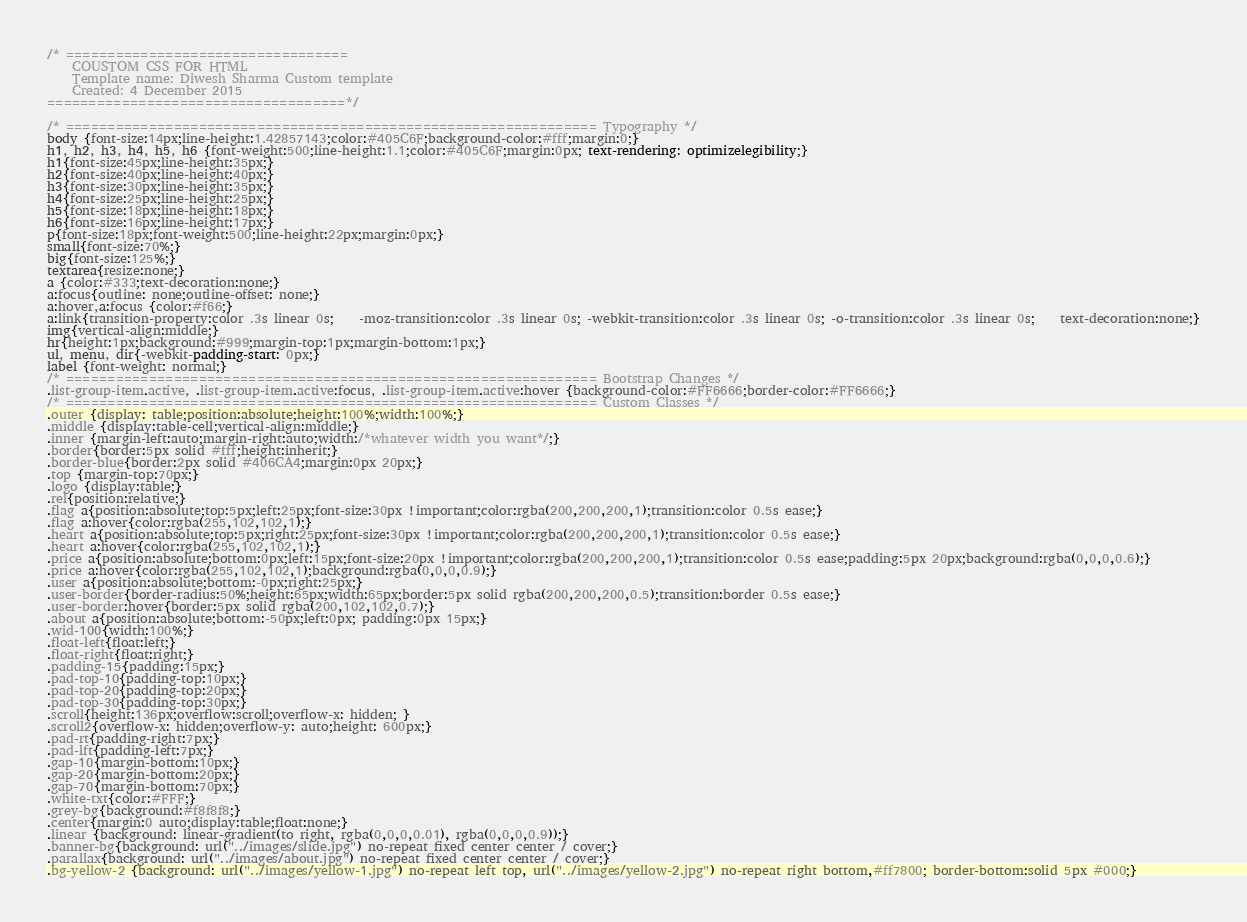<code> <loc_0><loc_0><loc_500><loc_500><_CSS_>/* ==================================
	COUSTOM CSS FOR HTML
	Template name: Diwesh Sharma Custom template
	Created: 4 December 2015       
====================================*/

/* ================================================================ Typography */
body {font-size:14px;line-height:1.42857143;color:#405C6F;background-color:#fff;margin:0;}
h1, h2, h3, h4, h5, h6 {font-weight:500;line-height:1.1;color:#405C6F;margin:0px; text-rendering: optimizelegibility;}
h1{font-size:45px;line-height:35px;}
h2{font-size:40px;line-height:40px;}
h3{font-size:30px;line-height:35px;}
h4{font-size:25px;line-height:25px;}
h5{font-size:18px;line-height:18px;}
h6{font-size:16px;line-height:17px;}
p{font-size:18px;font-weight:500;line-height:22px;margin:0px;}
small{font-size:70%;}
big{font-size:125%;}
textarea{resize:none;}
a {color:#333;text-decoration:none;}
a:focus{outline: none;outline-offset: none;}
a:hover,a:focus {color:#f66;}
a:link{transition-property:color .3s linear 0s;	-moz-transition:color .3s linear 0s; -webkit-transition:color .3s linear 0s; -o-transition:color .3s linear 0s;	text-decoration:none;}
img{vertical-align:middle;}
hr{height:1px;background:#999;margin-top:1px;margin-bottom:1px;}
ul, menu, dir{-webkit-padding-start: 0px;}
label {font-weight: normal;}
/* ================================================================ Bootstrap Changes */
.list-group-item.active, .list-group-item.active:focus, .list-group-item.active:hover {background-color:#FF6666;border-color:#FF6666;}
/* ================================================================ Custom Classes */
.outer {display: table;position:absolute;height:100%;width:100%;}
.middle {display:table-cell;vertical-align:middle;}
.inner {margin-left:auto;margin-right:auto;width:/*whatever width you want*/;}
.border{border:5px solid #fff;height:inherit;}
.border-blue{border:2px solid #406CA4;margin:0px 20px;}
.top {margin-top:70px;}
.logo {display:table;}
.rel{position:relative;}
.flag a{position:absolute;top:5px;left:25px;font-size:30px !important;color:rgba(200,200,200,1);transition:color 0.5s ease;}
.flag a:hover{color:rgba(255,102,102,1);}
.heart a{position:absolute;top:5px;right:25px;font-size:30px !important;color:rgba(200,200,200,1);transition:color 0.5s ease;}
.heart a:hover{color:rgba(255,102,102,1);}
.price a{position:absolute;bottom:0px;left:15px;font-size:20px !important;color:rgba(200,200,200,1);transition:color 0.5s ease;padding:5px 20px;background:rgba(0,0,0,0.6);}
.price a:hover{color:rgba(255,102,102,1);background:rgba(0,0,0,0.9);}
.user a{position:absolute;bottom:-0px;right:25px;}
.user-border{border-radius:50%;height:65px;width:65px;border:5px solid rgba(200,200,200,0.5);transition:border 0.5s ease;}
.user-border:hover{border:5px solid rgba(200,102,102,0.7);}
.about a{position:absolute;bottom:-50px;left:0px; padding:0px 15px;}
.wid-100{width:100%;}
.float-left{float:left;}
.float-right{float:right;}
.padding-15{padding:15px;}
.pad-top-10{padding-top:10px;}
.pad-top-20{padding-top:20px;}
.pad-top-30{padding-top:30px;}
.scroll{height:136px;overflow:scroll;overflow-x: hidden; }
.scroll2{overflow-x: hidden;overflow-y: auto;height: 600px;}
.pad-rt{padding-right:7px;}
.pad-lft{padding-left:7px;}
.gap-10{margin-bottom:10px;}
.gap-20{margin-bottom:20px;}
.gap-70{margin-bottom:70px;}
.white-txt{color:#FFF;}
.grey-bg{background:#f8f8f8;}
.center{margin:0 auto;display:table;float:none;}
.linear {background: linear-gradient(to right, rgba(0,0,0,0.01), rgba(0,0,0,0.9));}
.banner-bg{background: url("../images/slide.jpg") no-repeat fixed center center / cover;}
.parallax{background: url("../images/about.jpg") no-repeat fixed center center / cover;}
.bg-yellow-2 {background: url("../images/yellow-1.jpg") no-repeat left top, url("../images/yellow-2.jpg") no-repeat right bottom,#ff7800; border-bottom:solid 5px #000;}</code> 